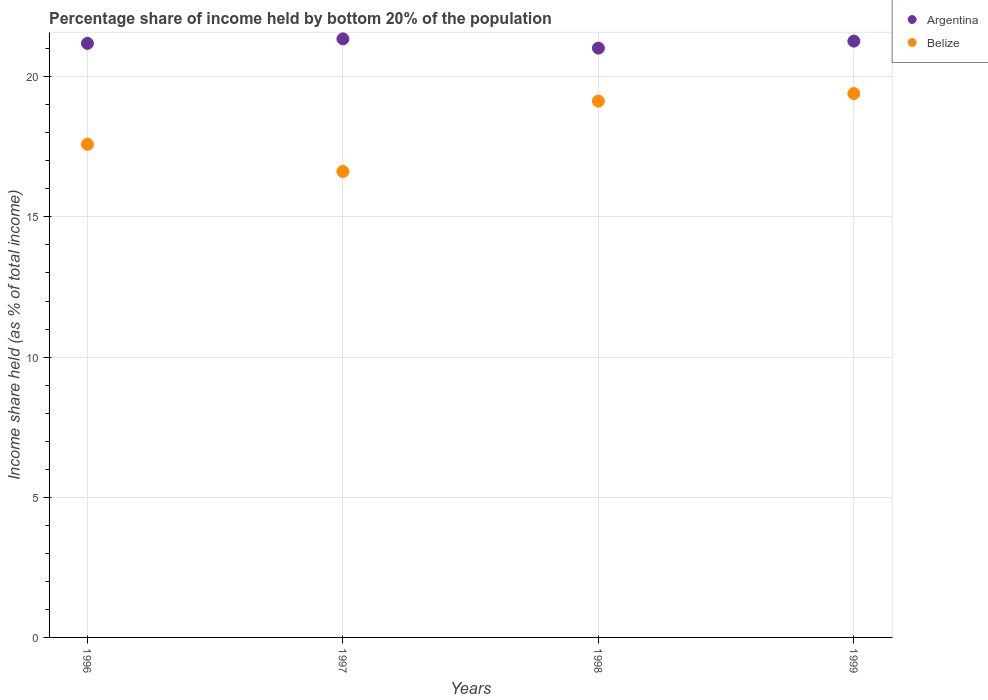How many different coloured dotlines are there?
Provide a succinct answer. 2. Is the number of dotlines equal to the number of legend labels?
Provide a succinct answer. Yes. What is the share of income held by bottom 20% of the population in Argentina in 1997?
Provide a succinct answer. 21.35. Across all years, what is the maximum share of income held by bottom 20% of the population in Belize?
Ensure brevity in your answer.  19.4. Across all years, what is the minimum share of income held by bottom 20% of the population in Argentina?
Provide a succinct answer. 21.02. In which year was the share of income held by bottom 20% of the population in Argentina minimum?
Ensure brevity in your answer.  1998. What is the total share of income held by bottom 20% of the population in Belize in the graph?
Give a very brief answer. 72.74. What is the difference between the share of income held by bottom 20% of the population in Belize in 1996 and that in 1997?
Provide a succinct answer. 0.97. What is the difference between the share of income held by bottom 20% of the population in Belize in 1998 and the share of income held by bottom 20% of the population in Argentina in 1997?
Keep it short and to the point. -2.22. What is the average share of income held by bottom 20% of the population in Argentina per year?
Keep it short and to the point. 21.21. In the year 1998, what is the difference between the share of income held by bottom 20% of the population in Argentina and share of income held by bottom 20% of the population in Belize?
Offer a terse response. 1.89. In how many years, is the share of income held by bottom 20% of the population in Belize greater than 16 %?
Provide a short and direct response. 4. What is the ratio of the share of income held by bottom 20% of the population in Belize in 1997 to that in 1998?
Your answer should be very brief. 0.87. Is the share of income held by bottom 20% of the population in Belize in 1996 less than that in 1999?
Offer a very short reply. Yes. Is the difference between the share of income held by bottom 20% of the population in Argentina in 1996 and 1998 greater than the difference between the share of income held by bottom 20% of the population in Belize in 1996 and 1998?
Make the answer very short. Yes. What is the difference between the highest and the second highest share of income held by bottom 20% of the population in Argentina?
Your response must be concise. 0.08. What is the difference between the highest and the lowest share of income held by bottom 20% of the population in Belize?
Provide a short and direct response. 2.78. In how many years, is the share of income held by bottom 20% of the population in Argentina greater than the average share of income held by bottom 20% of the population in Argentina taken over all years?
Give a very brief answer. 2. Is the sum of the share of income held by bottom 20% of the population in Belize in 1996 and 1997 greater than the maximum share of income held by bottom 20% of the population in Argentina across all years?
Your response must be concise. Yes. Does the share of income held by bottom 20% of the population in Argentina monotonically increase over the years?
Your answer should be very brief. No. How many dotlines are there?
Keep it short and to the point. 2. What is the difference between two consecutive major ticks on the Y-axis?
Provide a succinct answer. 5. Does the graph contain any zero values?
Ensure brevity in your answer.  No. Does the graph contain grids?
Keep it short and to the point. Yes. Where does the legend appear in the graph?
Give a very brief answer. Top right. How many legend labels are there?
Your answer should be very brief. 2. What is the title of the graph?
Provide a short and direct response. Percentage share of income held by bottom 20% of the population. What is the label or title of the Y-axis?
Your response must be concise. Income share held (as % of total income). What is the Income share held (as % of total income) of Argentina in 1996?
Offer a very short reply. 21.19. What is the Income share held (as % of total income) of Belize in 1996?
Give a very brief answer. 17.59. What is the Income share held (as % of total income) of Argentina in 1997?
Give a very brief answer. 21.35. What is the Income share held (as % of total income) of Belize in 1997?
Ensure brevity in your answer.  16.62. What is the Income share held (as % of total income) in Argentina in 1998?
Your answer should be compact. 21.02. What is the Income share held (as % of total income) of Belize in 1998?
Provide a succinct answer. 19.13. What is the Income share held (as % of total income) of Argentina in 1999?
Make the answer very short. 21.27. Across all years, what is the maximum Income share held (as % of total income) in Argentina?
Ensure brevity in your answer.  21.35. Across all years, what is the maximum Income share held (as % of total income) in Belize?
Your answer should be compact. 19.4. Across all years, what is the minimum Income share held (as % of total income) in Argentina?
Provide a succinct answer. 21.02. Across all years, what is the minimum Income share held (as % of total income) in Belize?
Your answer should be compact. 16.62. What is the total Income share held (as % of total income) in Argentina in the graph?
Make the answer very short. 84.83. What is the total Income share held (as % of total income) in Belize in the graph?
Your answer should be compact. 72.74. What is the difference between the Income share held (as % of total income) of Argentina in 1996 and that in 1997?
Your response must be concise. -0.16. What is the difference between the Income share held (as % of total income) of Belize in 1996 and that in 1997?
Make the answer very short. 0.97. What is the difference between the Income share held (as % of total income) in Argentina in 1996 and that in 1998?
Provide a short and direct response. 0.17. What is the difference between the Income share held (as % of total income) of Belize in 1996 and that in 1998?
Your response must be concise. -1.54. What is the difference between the Income share held (as % of total income) in Argentina in 1996 and that in 1999?
Ensure brevity in your answer.  -0.08. What is the difference between the Income share held (as % of total income) of Belize in 1996 and that in 1999?
Your response must be concise. -1.81. What is the difference between the Income share held (as % of total income) of Argentina in 1997 and that in 1998?
Ensure brevity in your answer.  0.33. What is the difference between the Income share held (as % of total income) of Belize in 1997 and that in 1998?
Keep it short and to the point. -2.51. What is the difference between the Income share held (as % of total income) of Belize in 1997 and that in 1999?
Ensure brevity in your answer.  -2.78. What is the difference between the Income share held (as % of total income) of Argentina in 1998 and that in 1999?
Provide a short and direct response. -0.25. What is the difference between the Income share held (as % of total income) in Belize in 1998 and that in 1999?
Ensure brevity in your answer.  -0.27. What is the difference between the Income share held (as % of total income) of Argentina in 1996 and the Income share held (as % of total income) of Belize in 1997?
Your answer should be compact. 4.57. What is the difference between the Income share held (as % of total income) in Argentina in 1996 and the Income share held (as % of total income) in Belize in 1998?
Your answer should be very brief. 2.06. What is the difference between the Income share held (as % of total income) in Argentina in 1996 and the Income share held (as % of total income) in Belize in 1999?
Offer a terse response. 1.79. What is the difference between the Income share held (as % of total income) of Argentina in 1997 and the Income share held (as % of total income) of Belize in 1998?
Your answer should be compact. 2.22. What is the difference between the Income share held (as % of total income) of Argentina in 1997 and the Income share held (as % of total income) of Belize in 1999?
Provide a succinct answer. 1.95. What is the difference between the Income share held (as % of total income) in Argentina in 1998 and the Income share held (as % of total income) in Belize in 1999?
Provide a short and direct response. 1.62. What is the average Income share held (as % of total income) of Argentina per year?
Offer a very short reply. 21.21. What is the average Income share held (as % of total income) in Belize per year?
Your response must be concise. 18.18. In the year 1996, what is the difference between the Income share held (as % of total income) in Argentina and Income share held (as % of total income) in Belize?
Offer a very short reply. 3.6. In the year 1997, what is the difference between the Income share held (as % of total income) in Argentina and Income share held (as % of total income) in Belize?
Your answer should be very brief. 4.73. In the year 1998, what is the difference between the Income share held (as % of total income) of Argentina and Income share held (as % of total income) of Belize?
Offer a very short reply. 1.89. In the year 1999, what is the difference between the Income share held (as % of total income) of Argentina and Income share held (as % of total income) of Belize?
Your response must be concise. 1.87. What is the ratio of the Income share held (as % of total income) of Belize in 1996 to that in 1997?
Your answer should be compact. 1.06. What is the ratio of the Income share held (as % of total income) in Belize in 1996 to that in 1998?
Give a very brief answer. 0.92. What is the ratio of the Income share held (as % of total income) of Belize in 1996 to that in 1999?
Provide a succinct answer. 0.91. What is the ratio of the Income share held (as % of total income) in Argentina in 1997 to that in 1998?
Offer a very short reply. 1.02. What is the ratio of the Income share held (as % of total income) of Belize in 1997 to that in 1998?
Your answer should be compact. 0.87. What is the ratio of the Income share held (as % of total income) in Argentina in 1997 to that in 1999?
Provide a short and direct response. 1. What is the ratio of the Income share held (as % of total income) in Belize in 1997 to that in 1999?
Offer a terse response. 0.86. What is the ratio of the Income share held (as % of total income) in Belize in 1998 to that in 1999?
Provide a short and direct response. 0.99. What is the difference between the highest and the second highest Income share held (as % of total income) in Belize?
Keep it short and to the point. 0.27. What is the difference between the highest and the lowest Income share held (as % of total income) of Argentina?
Give a very brief answer. 0.33. What is the difference between the highest and the lowest Income share held (as % of total income) in Belize?
Your answer should be very brief. 2.78. 